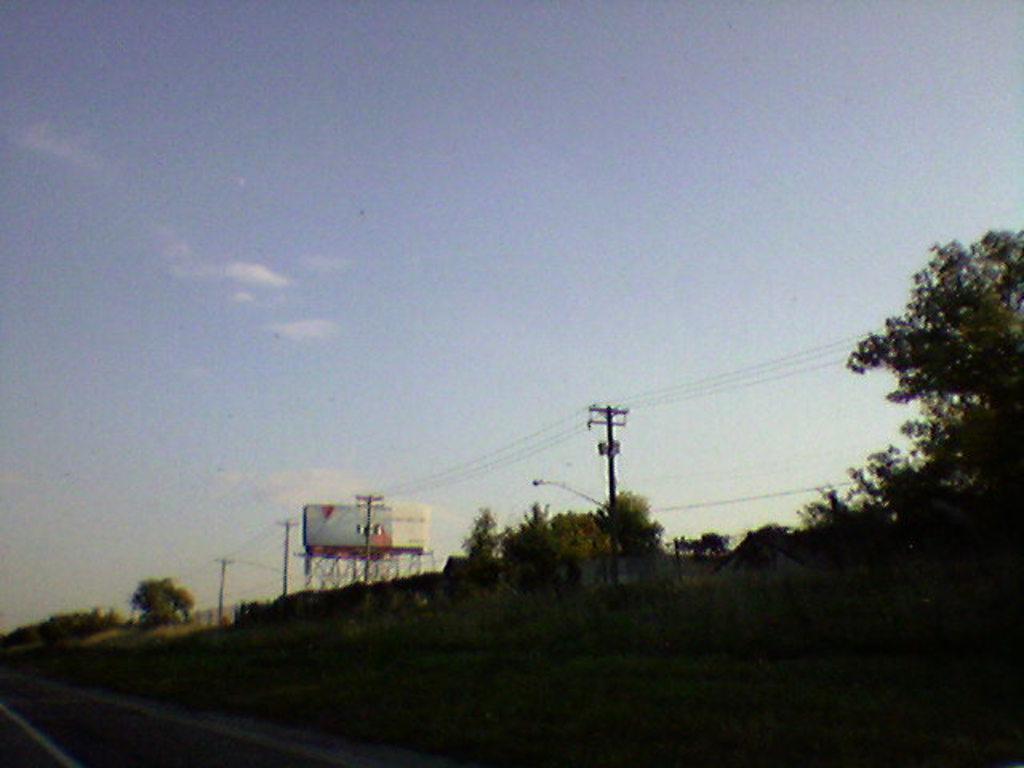Describe this image in one or two sentences. In the picture I can see few plants and trees and there are few poles,wires and some other objects in the background. 